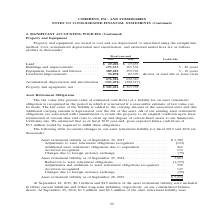According to Coherent's financial document, What is the useful life of Buildings and improvements? According to the financial document, 5 - 40 years. The relevant text states: ",655 Buildings and improvements . 173,333 165,535 5 - 40 years Equipment, furniture and fixtures . 389,225 359,721 3 - 10 years Leasehold improvements . 94,878 89..." Also, How is property and equipment stated in the table? stated at cost and are depreciated or amortized using the straight-line method. The document states: "Property and equipment are stated at cost and are depreciated or amortized using the straight-line method. Cost, accumulated depreciation and amortiza..." Also, In which years is information on Property and Equipment included in the table? The document shows two values: 2019 and 2018. From the document: "Fiscal year-end 2019 2018 Useful Life Fiscal year-end 2019 2018 Useful Life..." Additionally, In which year was the amount of Land larger? According to the financial document, 2019. The relevant text states: "Fiscal year-end 2019 2018 Useful Life..." Also, can you calculate: What was the change in Leasehold improvements from 2018 to 2019? Based on the calculation: 94,878-89,399, the result is 5479 (in thousands). This is based on the information: "225 359,721 3 - 10 years Leasehold improvements . 94,878 89,399 shorter of asset life or lease term ,721 3 - 10 years Leasehold improvements . 94,878 89,399 shorter of asset life or lease term..." The key data points involved are: 89,399, 94,878. Also, can you calculate: What was the percentage change in Leasehold improvements from 2018 to 2019? To answer this question, I need to perform calculations using the financial data. The calculation is: (94,878-89,399)/89,399, which equals 6.13 (percentage). This is based on the information: "225 359,721 3 - 10 years Leasehold improvements . 94,878 89,399 shorter of asset life or lease term ,721 3 - 10 years Leasehold improvements . 94,878 89,399 shorter of asset life or lease term..." The key data points involved are: 89,399, 94,878. 